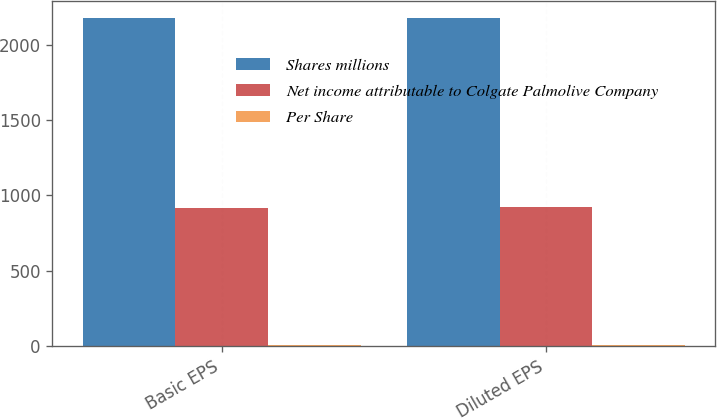Convert chart. <chart><loc_0><loc_0><loc_500><loc_500><stacked_bar_chart><ecel><fcel>Basic EPS<fcel>Diluted EPS<nl><fcel>Shares millions<fcel>2180<fcel>2180<nl><fcel>Net income attributable to Colgate Palmolive Company<fcel>915.1<fcel>924.3<nl><fcel>Per Share<fcel>2.38<fcel>2.36<nl></chart> 